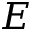<formula> <loc_0><loc_0><loc_500><loc_500>E</formula> 